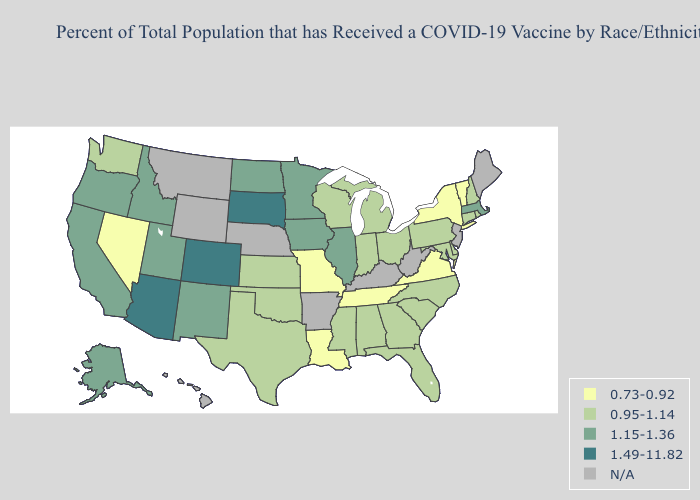Name the states that have a value in the range 1.15-1.36?
Concise answer only. Alaska, California, Idaho, Illinois, Iowa, Massachusetts, Minnesota, New Mexico, North Dakota, Oregon, Utah. Among the states that border Tennessee , which have the highest value?
Answer briefly. Alabama, Georgia, Mississippi, North Carolina. Does North Carolina have the highest value in the South?
Keep it brief. Yes. Name the states that have a value in the range 1.49-11.82?
Keep it brief. Arizona, Colorado, South Dakota. Does New Mexico have the lowest value in the West?
Quick response, please. No. Name the states that have a value in the range 0.73-0.92?
Concise answer only. Louisiana, Missouri, Nevada, New York, Tennessee, Vermont, Virginia. Name the states that have a value in the range 0.73-0.92?
Give a very brief answer. Louisiana, Missouri, Nevada, New York, Tennessee, Vermont, Virginia. What is the lowest value in the USA?
Give a very brief answer. 0.73-0.92. What is the lowest value in the MidWest?
Give a very brief answer. 0.73-0.92. Name the states that have a value in the range 0.73-0.92?
Keep it brief. Louisiana, Missouri, Nevada, New York, Tennessee, Vermont, Virginia. Name the states that have a value in the range 1.15-1.36?
Answer briefly. Alaska, California, Idaho, Illinois, Iowa, Massachusetts, Minnesota, New Mexico, North Dakota, Oregon, Utah. Which states have the lowest value in the USA?
Concise answer only. Louisiana, Missouri, Nevada, New York, Tennessee, Vermont, Virginia. Which states have the lowest value in the USA?
Keep it brief. Louisiana, Missouri, Nevada, New York, Tennessee, Vermont, Virginia. How many symbols are there in the legend?
Be succinct. 5. Name the states that have a value in the range 0.73-0.92?
Short answer required. Louisiana, Missouri, Nevada, New York, Tennessee, Vermont, Virginia. 